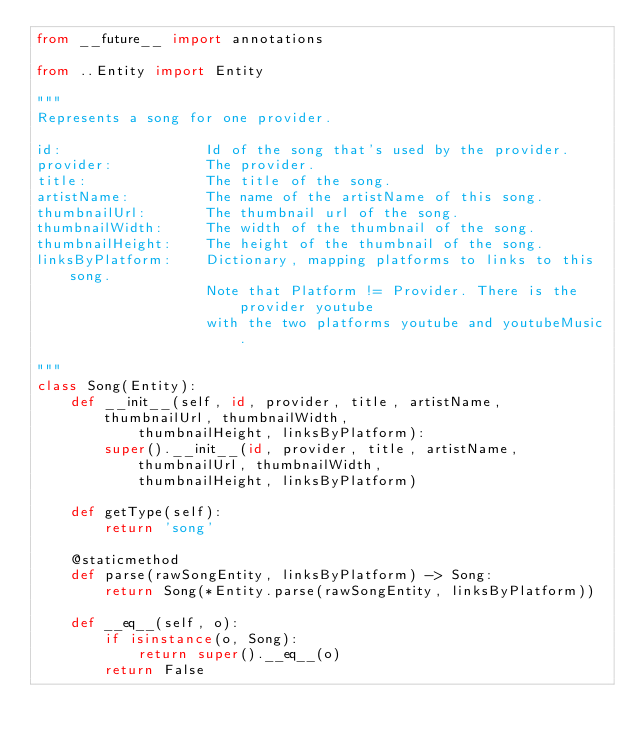Convert code to text. <code><loc_0><loc_0><loc_500><loc_500><_Python_>from __future__ import annotations

from ..Entity import Entity

"""
Represents a song for one provider.

id:                 Id of the song that's used by the provider.
provider:           The provider.
title:              The title of the song.
artistName:         The name of the artistName of this song.
thumbnailUrl:       The thumbnail url of the song.
thumbnailWidth:     The width of the thumbnail of the song.
thumbnailHeight:    The height of the thumbnail of the song.
linksByPlatform:    Dictionary, mapping platforms to links to this song.
                    Note that Platform != Provider. There is the provider youtube
                    with the two platforms youtube and youtubeMusic.

"""
class Song(Entity):
    def __init__(self, id, provider, title, artistName, thumbnailUrl, thumbnailWidth,
            thumbnailHeight, linksByPlatform):
        super().__init__(id, provider, title, artistName, thumbnailUrl, thumbnailWidth,
            thumbnailHeight, linksByPlatform)

    def getType(self):
        return 'song'

    @staticmethod
    def parse(rawSongEntity, linksByPlatform) -> Song:
        return Song(*Entity.parse(rawSongEntity, linksByPlatform))

    def __eq__(self, o):
        if isinstance(o, Song):
            return super().__eq__(o)
        return False
</code> 